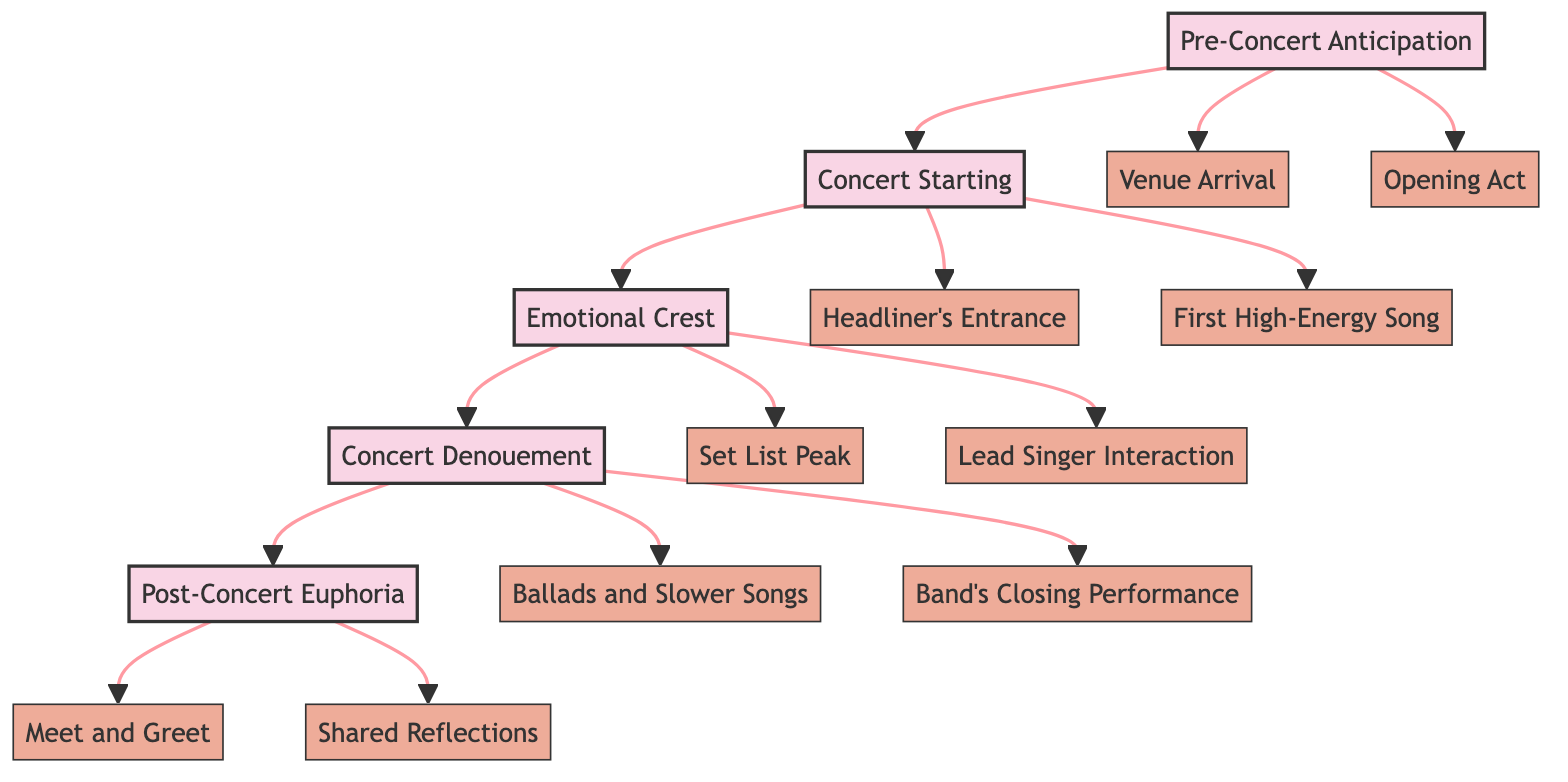What are the stages of the concert emotional flow? There are five stages in total: Pre-Concert Anticipation, Concert Starting, Emotional Crest, Concert Denouement, and Post-Concert Euphoria.
Answer: Five What is the first element in Stage 1? The first element in Stage 1 is "Venue Arrival," which describes fans arriving and excitement building.
Answer: Venue Arrival Which stage includes the "Headliner's Entrance"? The "Headliner's Entrance" is found in Stage 2, Concert Starting.
Answer: Stage 2 What element involves a lead singer's interaction? The element involving a lead singer's interaction is "Lead Singer Interaction," which heightens emotional connection.
Answer: Lead Singer Interaction How many elements are there in Stage 4? Stage 4, Concert Denouement, has two elements: "Ballads and Slower Songs" and "Band's Closing Performance."
Answer: Two What happens during the emotional crest? During the emotional crest, there is a "Set List Peak" with high-energy tracks and "Lead Singer Interaction" with the audience.
Answer: Set List Peak and Lead Singer Interaction Which stage includes the opportunity for a meet and greet? The opportunity for a meet and greet is included in Stage 5, Post-Concert Euphoria.
Answer: Stage 5 What best describes the transition in stage 4 of the concert? The transition in Stage 4 is marked by "Ballads and Slower Songs," allowing deeper emotional connection after high-energy songs.
Answer: Slower Songs What is the final element in the concert's emotional flow? The final element is "Shared Reflections," where fans relive their experience on social media.
Answer: Shared Reflections 